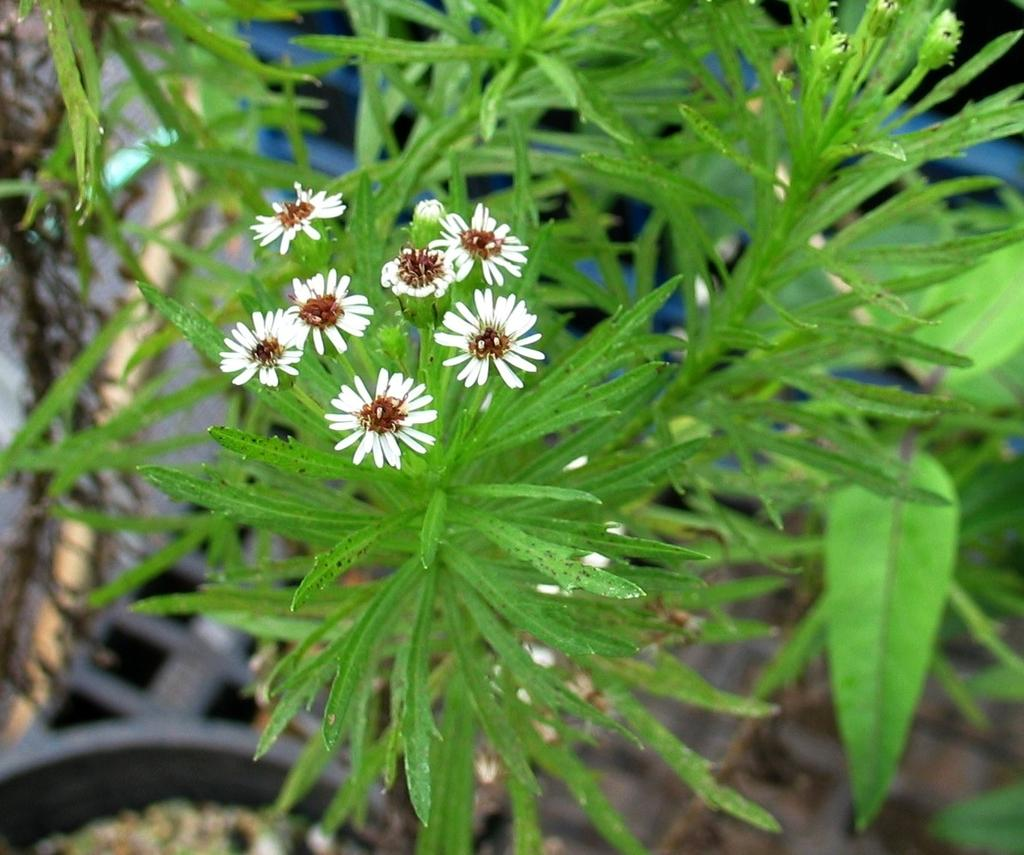What type of flowers can be seen in the image? There are white flowers in the image. Are the flowers part of a larger plant? Yes, the flowers are attached to a plant. What else can be seen on the plant besides the flowers? There are leaves in the image. What can be observed about the background of the image? The backdrop of the image is blurred. What type of food is being prepared in the image? There is no food present in the image; it features white flowers attached to a plant with leaves. What color is the yarn used to knit the sweater in the image? There is no sweater or yarn present in the image. 